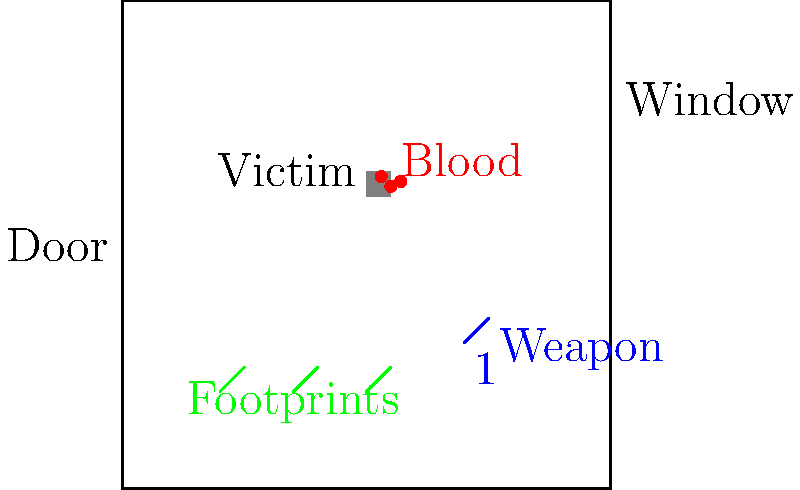As a lawyer examining a crime scene photograph, what crucial piece of evidence suggests the perpetrator's escape route, and how might this information be relevant to building your case? To answer this question, we need to analyze the crime scene diagram step by step:

1. Victim location: The victim is positioned in the center of the room.
2. Blood spatter: There are blood drops near the victim, indicating the crime's violent nature.
3. Weapon: A potential murder weapon is located in the lower right area of the room, marked with evidence tag "1".
4. Room exits: There are two potential exit points - a door on the left side and a window on the right side.
5. Footprints: Green footprints are visible leading from the crime scene towards the door.

The crucial piece of evidence suggesting the perpetrator's escape route is the set of footprints leading towards the door. This is significant for building the case because:

a) It indicates the direction of the perpetrator's movement after the crime.
b) It suggests the perpetrator left through the door, not the window.
c) The footprints may contain forensic evidence (shoe size, tread pattern) that can help identify the suspect.
d) The path of the footprints might reveal the perpetrator's familiarity with the layout of the room.
e) It could help establish a timeline of events and the perpetrator's actions post-crime.

This information is relevant to building the case as it provides physical evidence of the perpetrator's movements, narrows down the exit point, and offers potential leads for further investigation. It may also help in reconstructing the sequence of events and could be crucial in linking a suspect to the crime scene.
Answer: Footprints leading to the door 